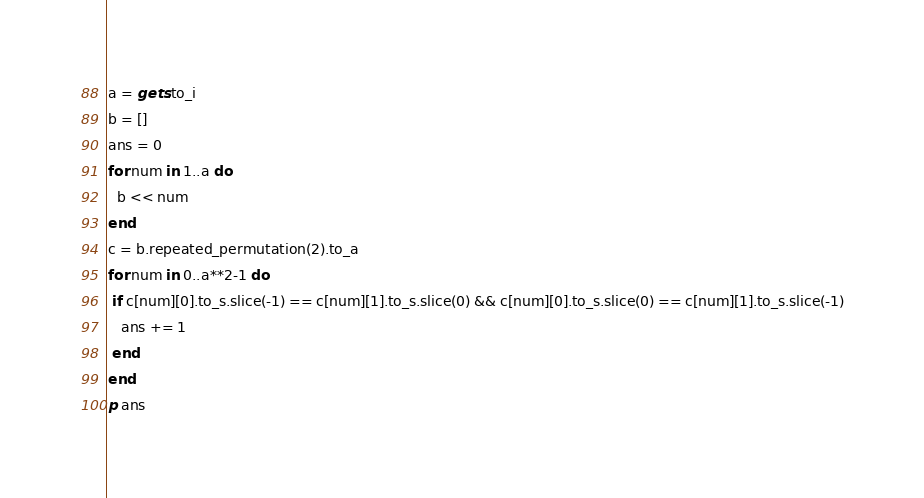Convert code to text. <code><loc_0><loc_0><loc_500><loc_500><_Ruby_>a = gets.to_i
b = []
ans = 0
for num in 1..a do
  b << num
end
c = b.repeated_permutation(2).to_a
for num in 0..a**2-1 do
 if c[num][0].to_s.slice(-1) == c[num][1].to_s.slice(0) && c[num][0].to_s.slice(0) == c[num][1].to_s.slice(-1)
   ans += 1
 end
end
p ans
</code> 